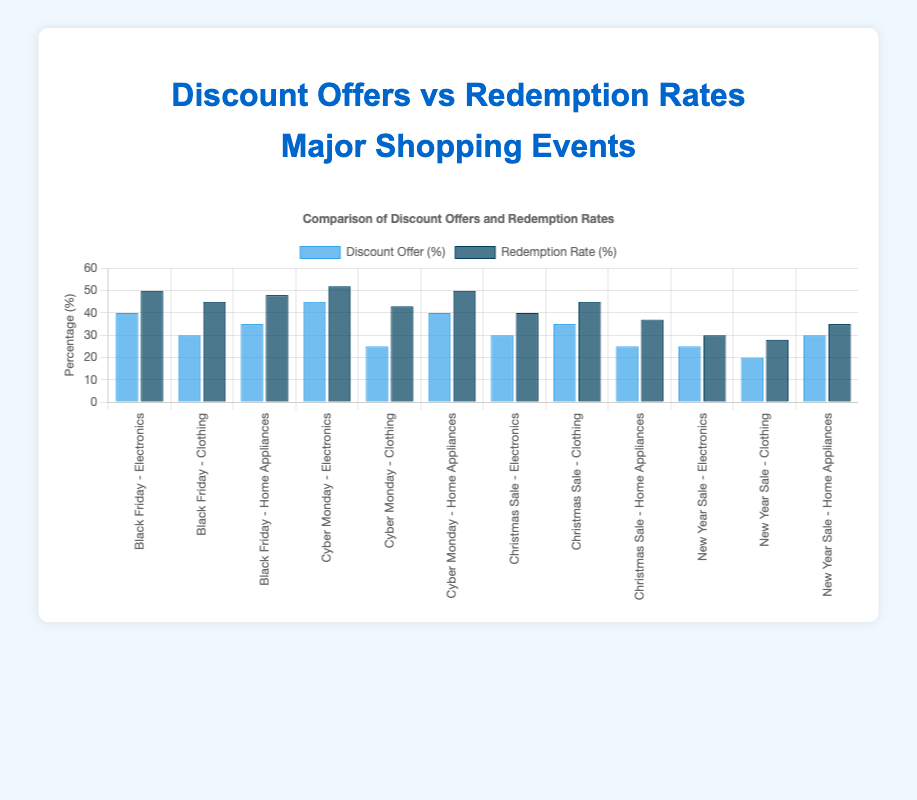What's the highest discount offer percentage for Electronics during the events? Look for the highest blue bar for Electronics across all events. The highest discount offer in Electronics is for Cyber Monday with 45%.
Answer: 45% Which event has the highest redemption rate for Home Appliances? Check the heights of the dark blue bars for Home Appliances across all events. Cyber Monday has the highest redemption rate for Home Appliances at 50%.
Answer: Cyber Monday Are there any events where the redemption rate percentage is greater than the discount offer percentage for Clothing? Compare the blue and dark blue bars for Clothing in each event. In all events (Black Friday, Cyber Monday, Christmas Sale, New Year Sale), the redemption rate is less than the discount offer.
Answer: No What's the difference in redemption rate percentages between Electronics and Clothing during Black Friday? Look at the dark blue bars for Electronics and Clothing under Black Friday. Redemption rates are 50% for Electronics and 45% for Clothing, resulting in a difference of 50% - 45% = 5%.
Answer: 5% During the Christmas Sale, what is the sum of the discount offers for all categories? Add up the blue bars for Christmas Sale; the sums are 30% for Electronics, 35% for Clothing, and 25% for Home Appliances: 30 + 35 + 25 = 90%.
Answer: 90% What is the average redemption rate percentage for Home Appliances across all events? Sum the redemption rate percentages for Home Appliances across all events: 48% (Black Friday) + 50% (Cyber Monday) + 37% (Christmas Sale) + 35% (New Year Sale) and divide by 4: (48 + 50 + 37 + 35) / 4 = 170 / 4 = 42.5%.
Answer: 42.5% Which category has a higher redemption rate, Electronics during Black Friday or Clothing during Cyber Monday? Compare the dark blue bars for Electronics during Black Friday (50%) and Clothing during Cyber Monday (43%). Electronics during Black Friday has a higher redemption rate.
Answer: Electronics during Black Friday Is there a consistent trend where the redemption rate is higher than the discount offer for any category? Examine each category's blue and dark blue bar heights across all events. Redemption rates always appear lower or equal to the discount offers in all categories across events.
Answer: No What are the discount offers for Home Appliances during Cyber Monday compared to New Year Sale? Look at the blue bars for Home Appliances in Cyber Monday and New Year Sale. Cyber Monday offers 40% and New Year Sale offers 30%.
Answer: Cyber Monday: 40%, New Year Sale: 30% During which event does Electronics have the lowest redemption rate? Check the dark blue bars for Electronics across all events. The lowest redemption rate for Electronics is during the New Year Sale at 30%.
Answer: New Year Sale 